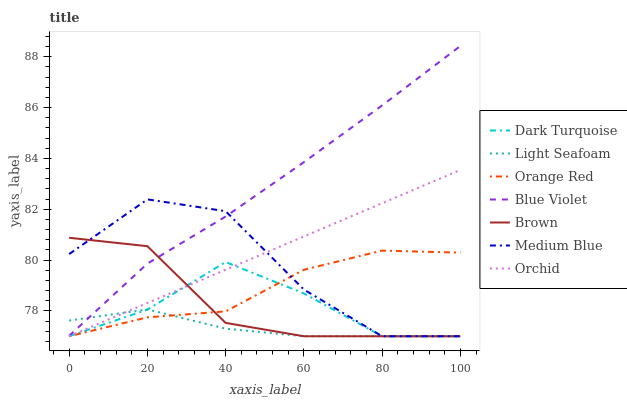Does Dark Turquoise have the minimum area under the curve?
Answer yes or no. No. Does Dark Turquoise have the maximum area under the curve?
Answer yes or no. No. Is Dark Turquoise the smoothest?
Answer yes or no. No. Is Dark Turquoise the roughest?
Answer yes or no. No. Does Blue Violet have the lowest value?
Answer yes or no. No. Does Dark Turquoise have the highest value?
Answer yes or no. No. Is Orchid less than Blue Violet?
Answer yes or no. Yes. Is Blue Violet greater than Dark Turquoise?
Answer yes or no. Yes. Does Orchid intersect Blue Violet?
Answer yes or no. No. 